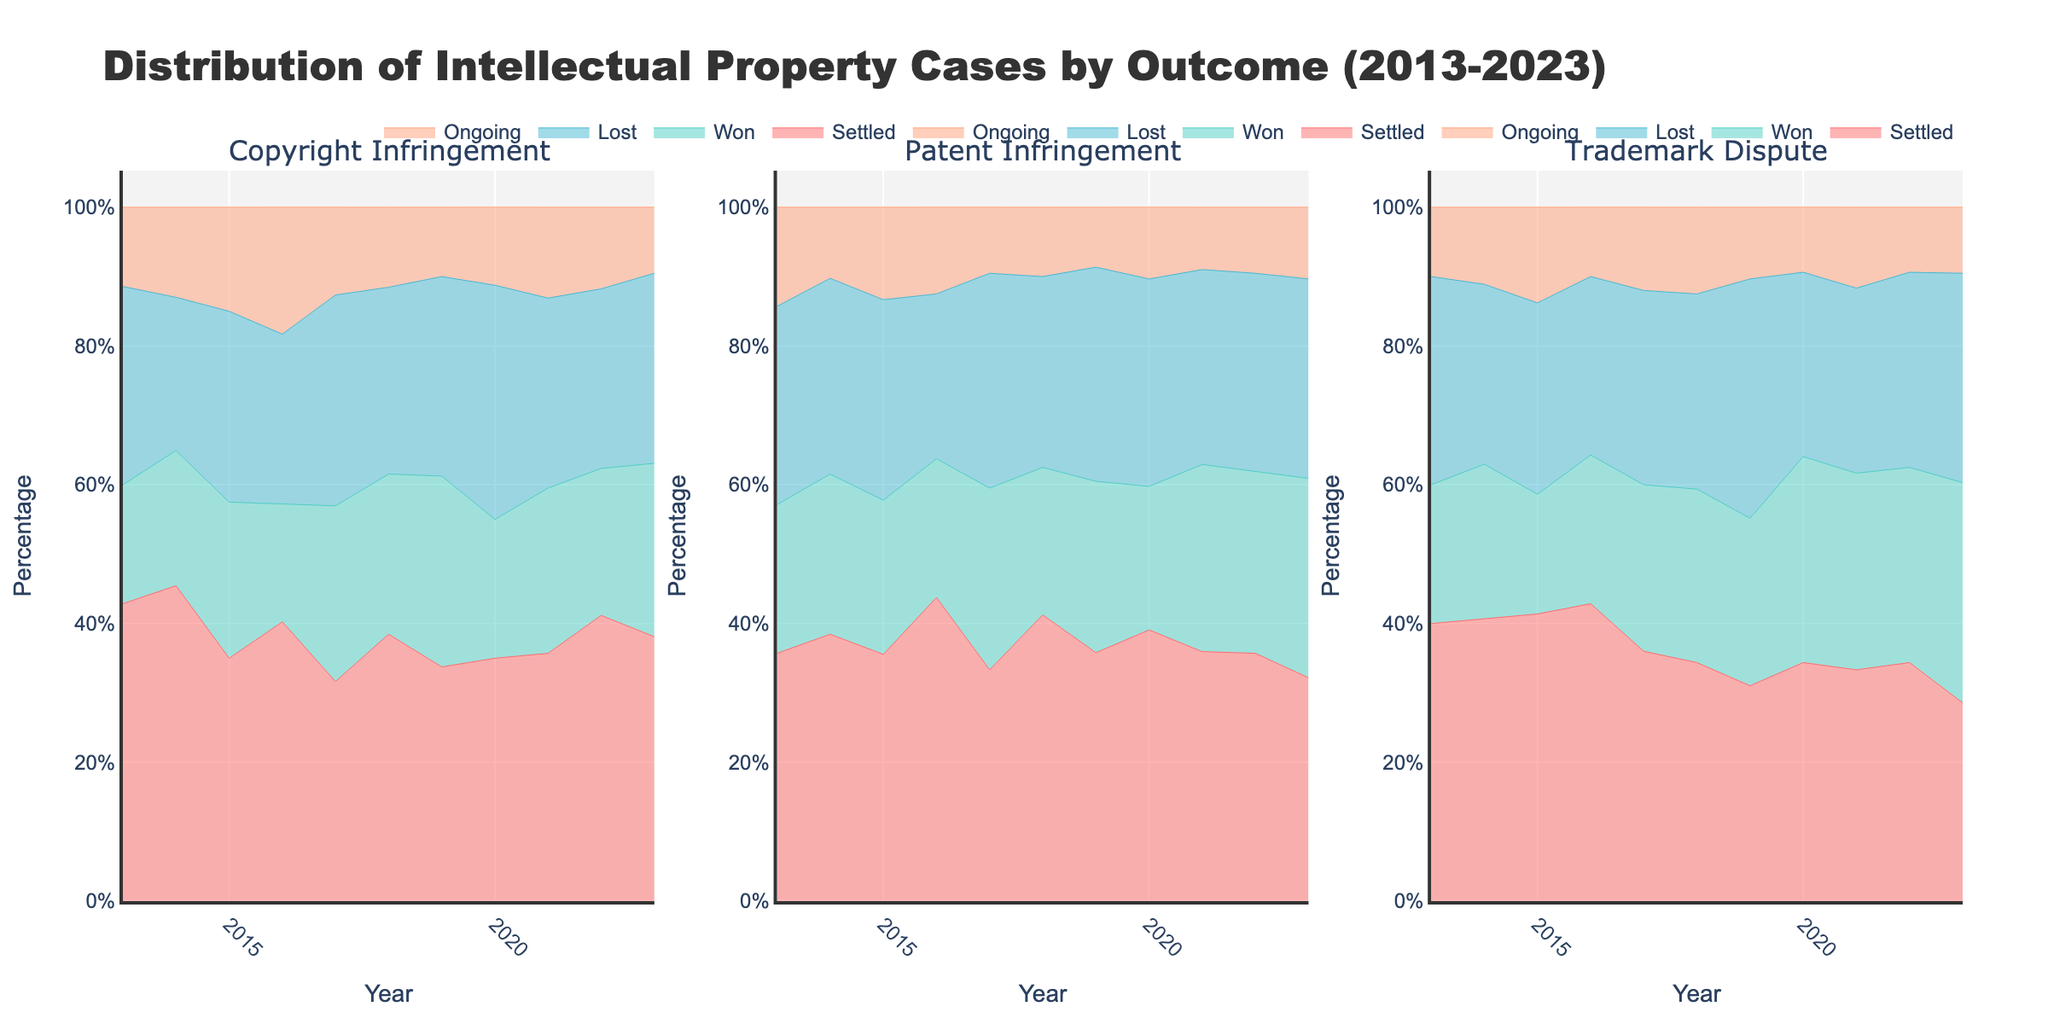What are the case types shown in the figure? The figure has a subplot for each of the three types of intellectual property cases: Copyright Infringement, Patent Infringement, and Trademark Dispute. These are indicated in the subplot titles.
Answer: Copyright Infringement, Patent Infringement, and Trademark Dispute In which year did Patent Infringement cases have the highest percentage of cases that were won? To find this, you would look at the segment representing the "Won" outcome in the Patent Infringement subplot. The highest point for this segment appears in 2023.
Answer: 2023 What general trend do you observe in the "Settled" outcome for Trademark Dispute cases from 2013 to 2023? To observe trends, examine the area plot for the "Settled" outcome in the Trademark Dispute subplot. The percentage of "Settled" cases shows a rising trend from 20% in 2013 to around 30% by 2023.
Answer: Rising trend In 2020, which type of case had the highest percentage of ongoing cases? To determine this, examine the "Ongoing" segment for each case type in the year 2020. The highest percentage belongs to the Copyright Infringement cases.
Answer: Copyright Infringement Between 2015 and 2017, did the percentage of "Lost" cases for Copyright Infringement increase, decrease, or remain stable? Compare the area representing the "Lost" outcome in the Copyright Infringement subplot at 2015, 2016, and 2017. The percentage increased from 22% in 2015 to 24% in 2017.
Answer: Increase Which case type had the most consistent percentage of "Won" outcomes over the decade? To determine consistency, consider how flat the "Won" outcome segment is over the decade. The Trademark Dispute cases have a relatively consistent percentage of around 17-20%.
Answer: Trademark Dispute By how much did the percentage of "Settled" cases for Copyright Infringement change from 2013 to 2023? Calculate the difference in the "Settled" percentage for Copyright Infringement between 2013 and 2023. It started at 30% in 2013 and ended at 32% in 2023.
Answer: Increased by 2% Which year saw the highest percentage of "Lost" outcomes for Trademark Dispute cases? To find the answer, examine the peak of the "Lost" outcome segment in the Trademark Dispute subplot. The highest percentage appears in 2019.
Answer: 2019 Compare the percentage of "Ongoing" cases for Patent Infringement in 2013 and 2023. Which year had a higher percentage? Look at the height of the "Ongoing" segment for Patent Infringement in 2013 and 2023. It was higher in 2013 with 10% compared to 9% in 2023.
Answer: 2013 